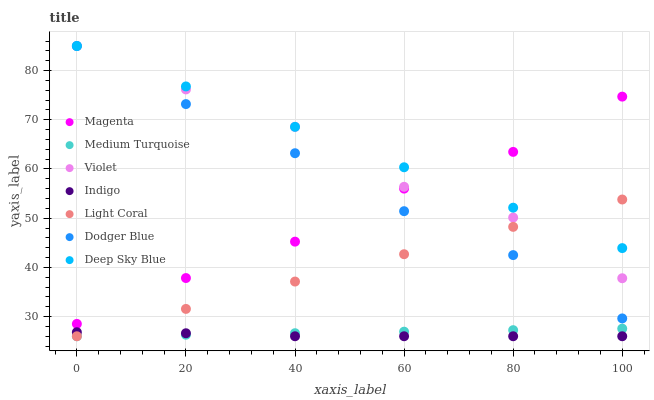Does Indigo have the minimum area under the curve?
Answer yes or no. Yes. Does Deep Sky Blue have the maximum area under the curve?
Answer yes or no. Yes. Does Light Coral have the minimum area under the curve?
Answer yes or no. No. Does Light Coral have the maximum area under the curve?
Answer yes or no. No. Is Medium Turquoise the smoothest?
Answer yes or no. Yes. Is Violet the roughest?
Answer yes or no. Yes. Is Deep Sky Blue the smoothest?
Answer yes or no. No. Is Deep Sky Blue the roughest?
Answer yes or no. No. Does Indigo have the lowest value?
Answer yes or no. Yes. Does Deep Sky Blue have the lowest value?
Answer yes or no. No. Does Violet have the highest value?
Answer yes or no. Yes. Does Light Coral have the highest value?
Answer yes or no. No. Is Indigo less than Magenta?
Answer yes or no. Yes. Is Deep Sky Blue greater than Indigo?
Answer yes or no. Yes. Does Dodger Blue intersect Violet?
Answer yes or no. Yes. Is Dodger Blue less than Violet?
Answer yes or no. No. Is Dodger Blue greater than Violet?
Answer yes or no. No. Does Indigo intersect Magenta?
Answer yes or no. No. 